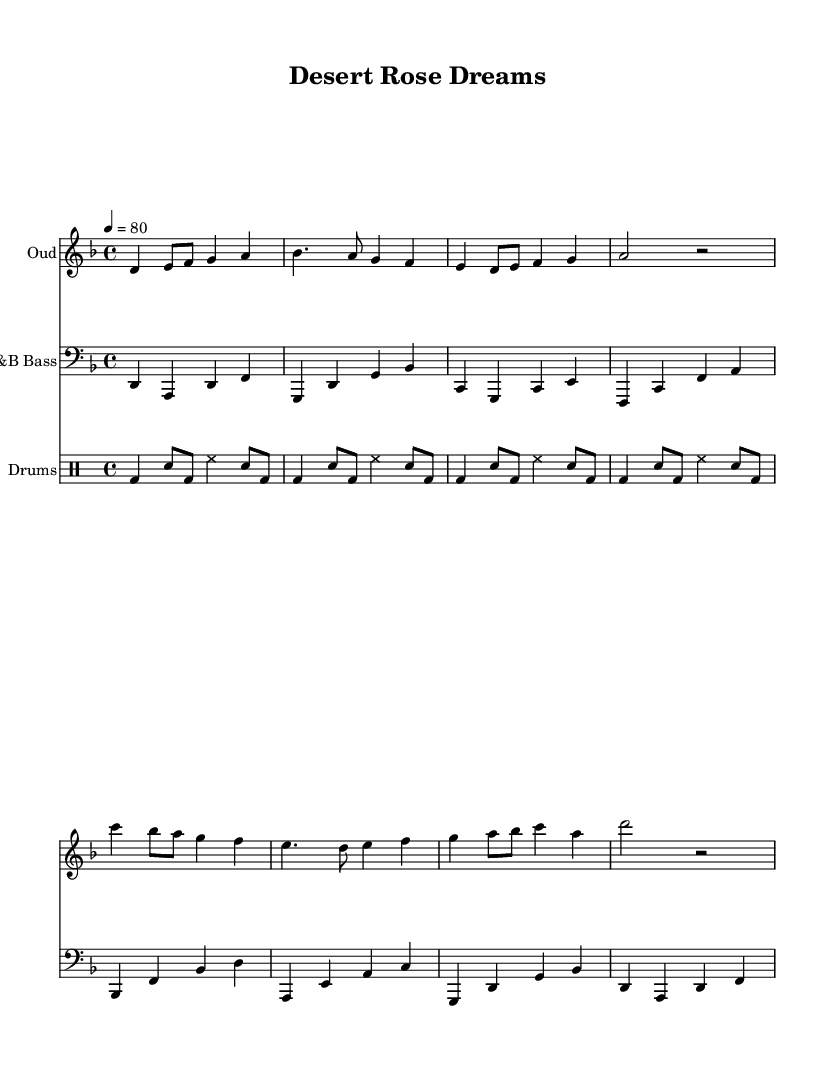What is the key signature of this music? The key signature is D minor, which contains one flat (B flat). This can be identified by looking for the flat sign on the staff, indicating the key.
Answer: D minor What is the time signature of this music? The time signature is 4/4, which can be determined by the numbers displayed at the start of the sheet music, indicating that there are four beats in each measure.
Answer: 4/4 What is the tempo marking of this piece? The tempo marking indicates 80 beats per minute, as shown following the tempo notation at the beginning of the score. This specifies how fast the music should be played.
Answer: 80 How many measures are in the oud part? Count the number of barlines in the oud staff to determine the number of measures. There are a total of eight measures present, indicated by the vertical lines on the staff.
Answer: Eight What pattern is repeated in the drum section? The drum pattern consists of a specific sequence of beats involving bass drums and snares, which is repeated four times, as seen in the drummode section.
Answer: Repeated pattern Which instrument is playing the bass line? The instrument playing the bass line is labeled as "R&B Bass," which can be found in the staff header. This indicates the genre and the specific instrumental role in this piece.
Answer: R&B Bass What is the total number of distinct instruments used in this score? There are three distinct instruments present: Oud, R&B Bass, and Drums, each represented by its own staff within the score. This can be deduced from the three separate staves listed at the beginning of the score.
Answer: Three 